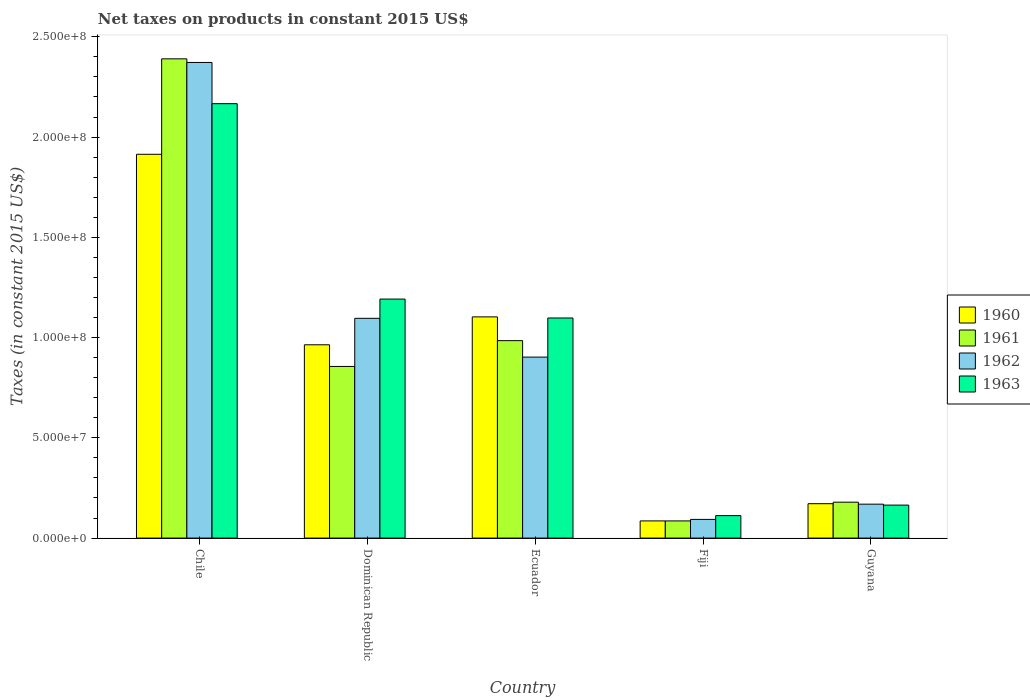How many different coloured bars are there?
Provide a succinct answer. 4. How many groups of bars are there?
Ensure brevity in your answer.  5. How many bars are there on the 5th tick from the right?
Offer a very short reply. 4. What is the label of the 5th group of bars from the left?
Offer a very short reply. Guyana. What is the net taxes on products in 1962 in Dominican Republic?
Keep it short and to the point. 1.10e+08. Across all countries, what is the maximum net taxes on products in 1963?
Make the answer very short. 2.17e+08. Across all countries, what is the minimum net taxes on products in 1963?
Give a very brief answer. 1.12e+07. In which country was the net taxes on products in 1962 minimum?
Keep it short and to the point. Fiji. What is the total net taxes on products in 1962 in the graph?
Your answer should be compact. 4.63e+08. What is the difference between the net taxes on products in 1961 in Chile and that in Ecuador?
Offer a terse response. 1.41e+08. What is the difference between the net taxes on products in 1963 in Dominican Republic and the net taxes on products in 1962 in Fiji?
Your response must be concise. 1.10e+08. What is the average net taxes on products in 1960 per country?
Your answer should be very brief. 8.48e+07. What is the difference between the net taxes on products of/in 1962 and net taxes on products of/in 1963 in Chile?
Provide a short and direct response. 2.06e+07. In how many countries, is the net taxes on products in 1961 greater than 230000000 US$?
Offer a very short reply. 1. What is the ratio of the net taxes on products in 1960 in Fiji to that in Guyana?
Offer a very short reply. 0.5. Is the net taxes on products in 1960 in Dominican Republic less than that in Fiji?
Offer a very short reply. No. What is the difference between the highest and the second highest net taxes on products in 1961?
Ensure brevity in your answer.  -1.29e+07. What is the difference between the highest and the lowest net taxes on products in 1962?
Your answer should be very brief. 2.28e+08. In how many countries, is the net taxes on products in 1960 greater than the average net taxes on products in 1960 taken over all countries?
Offer a very short reply. 3. Is the sum of the net taxes on products in 1961 in Chile and Dominican Republic greater than the maximum net taxes on products in 1962 across all countries?
Provide a short and direct response. Yes. Is it the case that in every country, the sum of the net taxes on products in 1962 and net taxes on products in 1960 is greater than the sum of net taxes on products in 1961 and net taxes on products in 1963?
Your answer should be compact. No. What does the 1st bar from the left in Ecuador represents?
Your answer should be compact. 1960. What does the 1st bar from the right in Dominican Republic represents?
Your answer should be compact. 1963. Is it the case that in every country, the sum of the net taxes on products in 1962 and net taxes on products in 1961 is greater than the net taxes on products in 1960?
Provide a succinct answer. Yes. Does the graph contain grids?
Give a very brief answer. No. Where does the legend appear in the graph?
Provide a short and direct response. Center right. How many legend labels are there?
Provide a short and direct response. 4. What is the title of the graph?
Make the answer very short. Net taxes on products in constant 2015 US$. Does "1969" appear as one of the legend labels in the graph?
Ensure brevity in your answer.  No. What is the label or title of the Y-axis?
Give a very brief answer. Taxes (in constant 2015 US$). What is the Taxes (in constant 2015 US$) of 1960 in Chile?
Give a very brief answer. 1.91e+08. What is the Taxes (in constant 2015 US$) of 1961 in Chile?
Ensure brevity in your answer.  2.39e+08. What is the Taxes (in constant 2015 US$) in 1962 in Chile?
Give a very brief answer. 2.37e+08. What is the Taxes (in constant 2015 US$) in 1963 in Chile?
Your answer should be compact. 2.17e+08. What is the Taxes (in constant 2015 US$) in 1960 in Dominican Republic?
Offer a very short reply. 9.64e+07. What is the Taxes (in constant 2015 US$) in 1961 in Dominican Republic?
Give a very brief answer. 8.56e+07. What is the Taxes (in constant 2015 US$) in 1962 in Dominican Republic?
Offer a terse response. 1.10e+08. What is the Taxes (in constant 2015 US$) of 1963 in Dominican Republic?
Your answer should be very brief. 1.19e+08. What is the Taxes (in constant 2015 US$) in 1960 in Ecuador?
Keep it short and to the point. 1.10e+08. What is the Taxes (in constant 2015 US$) in 1961 in Ecuador?
Ensure brevity in your answer.  9.85e+07. What is the Taxes (in constant 2015 US$) of 1962 in Ecuador?
Your response must be concise. 9.03e+07. What is the Taxes (in constant 2015 US$) of 1963 in Ecuador?
Make the answer very short. 1.10e+08. What is the Taxes (in constant 2015 US$) of 1960 in Fiji?
Make the answer very short. 8.56e+06. What is the Taxes (in constant 2015 US$) in 1961 in Fiji?
Offer a terse response. 8.56e+06. What is the Taxes (in constant 2015 US$) of 1962 in Fiji?
Provide a short and direct response. 9.32e+06. What is the Taxes (in constant 2015 US$) of 1963 in Fiji?
Your response must be concise. 1.12e+07. What is the Taxes (in constant 2015 US$) of 1960 in Guyana?
Offer a terse response. 1.71e+07. What is the Taxes (in constant 2015 US$) in 1961 in Guyana?
Keep it short and to the point. 1.79e+07. What is the Taxes (in constant 2015 US$) in 1962 in Guyana?
Offer a terse response. 1.69e+07. What is the Taxes (in constant 2015 US$) of 1963 in Guyana?
Your response must be concise. 1.64e+07. Across all countries, what is the maximum Taxes (in constant 2015 US$) in 1960?
Provide a succinct answer. 1.91e+08. Across all countries, what is the maximum Taxes (in constant 2015 US$) in 1961?
Give a very brief answer. 2.39e+08. Across all countries, what is the maximum Taxes (in constant 2015 US$) of 1962?
Make the answer very short. 2.37e+08. Across all countries, what is the maximum Taxes (in constant 2015 US$) in 1963?
Provide a succinct answer. 2.17e+08. Across all countries, what is the minimum Taxes (in constant 2015 US$) of 1960?
Your response must be concise. 8.56e+06. Across all countries, what is the minimum Taxes (in constant 2015 US$) of 1961?
Make the answer very short. 8.56e+06. Across all countries, what is the minimum Taxes (in constant 2015 US$) of 1962?
Offer a very short reply. 9.32e+06. Across all countries, what is the minimum Taxes (in constant 2015 US$) in 1963?
Provide a succinct answer. 1.12e+07. What is the total Taxes (in constant 2015 US$) of 1960 in the graph?
Ensure brevity in your answer.  4.24e+08. What is the total Taxes (in constant 2015 US$) in 1961 in the graph?
Your answer should be very brief. 4.50e+08. What is the total Taxes (in constant 2015 US$) in 1962 in the graph?
Your answer should be compact. 4.63e+08. What is the total Taxes (in constant 2015 US$) in 1963 in the graph?
Give a very brief answer. 4.73e+08. What is the difference between the Taxes (in constant 2015 US$) of 1960 in Chile and that in Dominican Republic?
Offer a terse response. 9.50e+07. What is the difference between the Taxes (in constant 2015 US$) of 1961 in Chile and that in Dominican Republic?
Your answer should be very brief. 1.53e+08. What is the difference between the Taxes (in constant 2015 US$) of 1962 in Chile and that in Dominican Republic?
Offer a very short reply. 1.28e+08. What is the difference between the Taxes (in constant 2015 US$) of 1963 in Chile and that in Dominican Republic?
Your answer should be very brief. 9.74e+07. What is the difference between the Taxes (in constant 2015 US$) in 1960 in Chile and that in Ecuador?
Offer a very short reply. 8.11e+07. What is the difference between the Taxes (in constant 2015 US$) of 1961 in Chile and that in Ecuador?
Ensure brevity in your answer.  1.41e+08. What is the difference between the Taxes (in constant 2015 US$) of 1962 in Chile and that in Ecuador?
Give a very brief answer. 1.47e+08. What is the difference between the Taxes (in constant 2015 US$) in 1963 in Chile and that in Ecuador?
Give a very brief answer. 1.07e+08. What is the difference between the Taxes (in constant 2015 US$) of 1960 in Chile and that in Fiji?
Provide a succinct answer. 1.83e+08. What is the difference between the Taxes (in constant 2015 US$) in 1961 in Chile and that in Fiji?
Your answer should be very brief. 2.30e+08. What is the difference between the Taxes (in constant 2015 US$) in 1962 in Chile and that in Fiji?
Offer a terse response. 2.28e+08. What is the difference between the Taxes (in constant 2015 US$) of 1963 in Chile and that in Fiji?
Keep it short and to the point. 2.05e+08. What is the difference between the Taxes (in constant 2015 US$) in 1960 in Chile and that in Guyana?
Offer a terse response. 1.74e+08. What is the difference between the Taxes (in constant 2015 US$) in 1961 in Chile and that in Guyana?
Ensure brevity in your answer.  2.21e+08. What is the difference between the Taxes (in constant 2015 US$) of 1962 in Chile and that in Guyana?
Your answer should be very brief. 2.20e+08. What is the difference between the Taxes (in constant 2015 US$) in 1963 in Chile and that in Guyana?
Your response must be concise. 2.00e+08. What is the difference between the Taxes (in constant 2015 US$) in 1960 in Dominican Republic and that in Ecuador?
Your answer should be compact. -1.39e+07. What is the difference between the Taxes (in constant 2015 US$) of 1961 in Dominican Republic and that in Ecuador?
Offer a very short reply. -1.29e+07. What is the difference between the Taxes (in constant 2015 US$) in 1962 in Dominican Republic and that in Ecuador?
Your answer should be very brief. 1.93e+07. What is the difference between the Taxes (in constant 2015 US$) in 1963 in Dominican Republic and that in Ecuador?
Offer a terse response. 9.44e+06. What is the difference between the Taxes (in constant 2015 US$) in 1960 in Dominican Republic and that in Fiji?
Offer a very short reply. 8.78e+07. What is the difference between the Taxes (in constant 2015 US$) of 1961 in Dominican Republic and that in Fiji?
Offer a very short reply. 7.70e+07. What is the difference between the Taxes (in constant 2015 US$) in 1962 in Dominican Republic and that in Fiji?
Keep it short and to the point. 1.00e+08. What is the difference between the Taxes (in constant 2015 US$) in 1963 in Dominican Republic and that in Fiji?
Keep it short and to the point. 1.08e+08. What is the difference between the Taxes (in constant 2015 US$) of 1960 in Dominican Republic and that in Guyana?
Give a very brief answer. 7.93e+07. What is the difference between the Taxes (in constant 2015 US$) of 1961 in Dominican Republic and that in Guyana?
Ensure brevity in your answer.  6.77e+07. What is the difference between the Taxes (in constant 2015 US$) of 1962 in Dominican Republic and that in Guyana?
Give a very brief answer. 9.27e+07. What is the difference between the Taxes (in constant 2015 US$) in 1963 in Dominican Republic and that in Guyana?
Your answer should be compact. 1.03e+08. What is the difference between the Taxes (in constant 2015 US$) of 1960 in Ecuador and that in Fiji?
Keep it short and to the point. 1.02e+08. What is the difference between the Taxes (in constant 2015 US$) in 1961 in Ecuador and that in Fiji?
Your answer should be very brief. 8.99e+07. What is the difference between the Taxes (in constant 2015 US$) in 1962 in Ecuador and that in Fiji?
Provide a succinct answer. 8.09e+07. What is the difference between the Taxes (in constant 2015 US$) in 1963 in Ecuador and that in Fiji?
Your response must be concise. 9.86e+07. What is the difference between the Taxes (in constant 2015 US$) of 1960 in Ecuador and that in Guyana?
Your answer should be very brief. 9.32e+07. What is the difference between the Taxes (in constant 2015 US$) in 1961 in Ecuador and that in Guyana?
Your answer should be very brief. 8.06e+07. What is the difference between the Taxes (in constant 2015 US$) in 1962 in Ecuador and that in Guyana?
Offer a terse response. 7.33e+07. What is the difference between the Taxes (in constant 2015 US$) of 1963 in Ecuador and that in Guyana?
Provide a succinct answer. 9.33e+07. What is the difference between the Taxes (in constant 2015 US$) in 1960 in Fiji and that in Guyana?
Ensure brevity in your answer.  -8.59e+06. What is the difference between the Taxes (in constant 2015 US$) of 1961 in Fiji and that in Guyana?
Your answer should be very brief. -9.34e+06. What is the difference between the Taxes (in constant 2015 US$) in 1962 in Fiji and that in Guyana?
Give a very brief answer. -7.60e+06. What is the difference between the Taxes (in constant 2015 US$) of 1963 in Fiji and that in Guyana?
Ensure brevity in your answer.  -5.24e+06. What is the difference between the Taxes (in constant 2015 US$) of 1960 in Chile and the Taxes (in constant 2015 US$) of 1961 in Dominican Republic?
Your answer should be compact. 1.06e+08. What is the difference between the Taxes (in constant 2015 US$) of 1960 in Chile and the Taxes (in constant 2015 US$) of 1962 in Dominican Republic?
Keep it short and to the point. 8.18e+07. What is the difference between the Taxes (in constant 2015 US$) of 1960 in Chile and the Taxes (in constant 2015 US$) of 1963 in Dominican Republic?
Provide a succinct answer. 7.22e+07. What is the difference between the Taxes (in constant 2015 US$) in 1961 in Chile and the Taxes (in constant 2015 US$) in 1962 in Dominican Republic?
Your response must be concise. 1.29e+08. What is the difference between the Taxes (in constant 2015 US$) of 1961 in Chile and the Taxes (in constant 2015 US$) of 1963 in Dominican Republic?
Offer a very short reply. 1.20e+08. What is the difference between the Taxes (in constant 2015 US$) of 1962 in Chile and the Taxes (in constant 2015 US$) of 1963 in Dominican Republic?
Give a very brief answer. 1.18e+08. What is the difference between the Taxes (in constant 2015 US$) in 1960 in Chile and the Taxes (in constant 2015 US$) in 1961 in Ecuador?
Your answer should be compact. 9.29e+07. What is the difference between the Taxes (in constant 2015 US$) in 1960 in Chile and the Taxes (in constant 2015 US$) in 1962 in Ecuador?
Offer a terse response. 1.01e+08. What is the difference between the Taxes (in constant 2015 US$) of 1960 in Chile and the Taxes (in constant 2015 US$) of 1963 in Ecuador?
Provide a short and direct response. 8.16e+07. What is the difference between the Taxes (in constant 2015 US$) of 1961 in Chile and the Taxes (in constant 2015 US$) of 1962 in Ecuador?
Offer a very short reply. 1.49e+08. What is the difference between the Taxes (in constant 2015 US$) of 1961 in Chile and the Taxes (in constant 2015 US$) of 1963 in Ecuador?
Make the answer very short. 1.29e+08. What is the difference between the Taxes (in constant 2015 US$) in 1962 in Chile and the Taxes (in constant 2015 US$) in 1963 in Ecuador?
Provide a short and direct response. 1.27e+08. What is the difference between the Taxes (in constant 2015 US$) of 1960 in Chile and the Taxes (in constant 2015 US$) of 1961 in Fiji?
Provide a succinct answer. 1.83e+08. What is the difference between the Taxes (in constant 2015 US$) of 1960 in Chile and the Taxes (in constant 2015 US$) of 1962 in Fiji?
Provide a succinct answer. 1.82e+08. What is the difference between the Taxes (in constant 2015 US$) in 1960 in Chile and the Taxes (in constant 2015 US$) in 1963 in Fiji?
Provide a short and direct response. 1.80e+08. What is the difference between the Taxes (in constant 2015 US$) of 1961 in Chile and the Taxes (in constant 2015 US$) of 1962 in Fiji?
Offer a very short reply. 2.30e+08. What is the difference between the Taxes (in constant 2015 US$) of 1961 in Chile and the Taxes (in constant 2015 US$) of 1963 in Fiji?
Give a very brief answer. 2.28e+08. What is the difference between the Taxes (in constant 2015 US$) in 1962 in Chile and the Taxes (in constant 2015 US$) in 1963 in Fiji?
Keep it short and to the point. 2.26e+08. What is the difference between the Taxes (in constant 2015 US$) of 1960 in Chile and the Taxes (in constant 2015 US$) of 1961 in Guyana?
Your answer should be very brief. 1.73e+08. What is the difference between the Taxes (in constant 2015 US$) in 1960 in Chile and the Taxes (in constant 2015 US$) in 1962 in Guyana?
Ensure brevity in your answer.  1.74e+08. What is the difference between the Taxes (in constant 2015 US$) in 1960 in Chile and the Taxes (in constant 2015 US$) in 1963 in Guyana?
Make the answer very short. 1.75e+08. What is the difference between the Taxes (in constant 2015 US$) in 1961 in Chile and the Taxes (in constant 2015 US$) in 1962 in Guyana?
Your answer should be compact. 2.22e+08. What is the difference between the Taxes (in constant 2015 US$) in 1961 in Chile and the Taxes (in constant 2015 US$) in 1963 in Guyana?
Keep it short and to the point. 2.23e+08. What is the difference between the Taxes (in constant 2015 US$) in 1962 in Chile and the Taxes (in constant 2015 US$) in 1963 in Guyana?
Keep it short and to the point. 2.21e+08. What is the difference between the Taxes (in constant 2015 US$) in 1960 in Dominican Republic and the Taxes (in constant 2015 US$) in 1961 in Ecuador?
Offer a very short reply. -2.07e+06. What is the difference between the Taxes (in constant 2015 US$) in 1960 in Dominican Republic and the Taxes (in constant 2015 US$) in 1962 in Ecuador?
Provide a succinct answer. 6.14e+06. What is the difference between the Taxes (in constant 2015 US$) of 1960 in Dominican Republic and the Taxes (in constant 2015 US$) of 1963 in Ecuador?
Give a very brief answer. -1.34e+07. What is the difference between the Taxes (in constant 2015 US$) of 1961 in Dominican Republic and the Taxes (in constant 2015 US$) of 1962 in Ecuador?
Provide a succinct answer. -4.66e+06. What is the difference between the Taxes (in constant 2015 US$) of 1961 in Dominican Republic and the Taxes (in constant 2015 US$) of 1963 in Ecuador?
Your response must be concise. -2.42e+07. What is the difference between the Taxes (in constant 2015 US$) of 1962 in Dominican Republic and the Taxes (in constant 2015 US$) of 1963 in Ecuador?
Provide a succinct answer. -1.64e+05. What is the difference between the Taxes (in constant 2015 US$) of 1960 in Dominican Republic and the Taxes (in constant 2015 US$) of 1961 in Fiji?
Offer a very short reply. 8.78e+07. What is the difference between the Taxes (in constant 2015 US$) of 1960 in Dominican Republic and the Taxes (in constant 2015 US$) of 1962 in Fiji?
Keep it short and to the point. 8.71e+07. What is the difference between the Taxes (in constant 2015 US$) of 1960 in Dominican Republic and the Taxes (in constant 2015 US$) of 1963 in Fiji?
Ensure brevity in your answer.  8.52e+07. What is the difference between the Taxes (in constant 2015 US$) of 1961 in Dominican Republic and the Taxes (in constant 2015 US$) of 1962 in Fiji?
Provide a short and direct response. 7.63e+07. What is the difference between the Taxes (in constant 2015 US$) of 1961 in Dominican Republic and the Taxes (in constant 2015 US$) of 1963 in Fiji?
Offer a very short reply. 7.44e+07. What is the difference between the Taxes (in constant 2015 US$) of 1962 in Dominican Republic and the Taxes (in constant 2015 US$) of 1963 in Fiji?
Keep it short and to the point. 9.84e+07. What is the difference between the Taxes (in constant 2015 US$) of 1960 in Dominican Republic and the Taxes (in constant 2015 US$) of 1961 in Guyana?
Your answer should be compact. 7.85e+07. What is the difference between the Taxes (in constant 2015 US$) in 1960 in Dominican Republic and the Taxes (in constant 2015 US$) in 1962 in Guyana?
Your answer should be compact. 7.95e+07. What is the difference between the Taxes (in constant 2015 US$) in 1960 in Dominican Republic and the Taxes (in constant 2015 US$) in 1963 in Guyana?
Provide a short and direct response. 8.00e+07. What is the difference between the Taxes (in constant 2015 US$) in 1961 in Dominican Republic and the Taxes (in constant 2015 US$) in 1962 in Guyana?
Offer a very short reply. 6.87e+07. What is the difference between the Taxes (in constant 2015 US$) in 1961 in Dominican Republic and the Taxes (in constant 2015 US$) in 1963 in Guyana?
Offer a terse response. 6.92e+07. What is the difference between the Taxes (in constant 2015 US$) of 1962 in Dominican Republic and the Taxes (in constant 2015 US$) of 1963 in Guyana?
Your response must be concise. 9.32e+07. What is the difference between the Taxes (in constant 2015 US$) of 1960 in Ecuador and the Taxes (in constant 2015 US$) of 1961 in Fiji?
Offer a terse response. 1.02e+08. What is the difference between the Taxes (in constant 2015 US$) in 1960 in Ecuador and the Taxes (in constant 2015 US$) in 1962 in Fiji?
Keep it short and to the point. 1.01e+08. What is the difference between the Taxes (in constant 2015 US$) in 1960 in Ecuador and the Taxes (in constant 2015 US$) in 1963 in Fiji?
Ensure brevity in your answer.  9.91e+07. What is the difference between the Taxes (in constant 2015 US$) in 1961 in Ecuador and the Taxes (in constant 2015 US$) in 1962 in Fiji?
Make the answer very short. 8.91e+07. What is the difference between the Taxes (in constant 2015 US$) of 1961 in Ecuador and the Taxes (in constant 2015 US$) of 1963 in Fiji?
Keep it short and to the point. 8.73e+07. What is the difference between the Taxes (in constant 2015 US$) in 1962 in Ecuador and the Taxes (in constant 2015 US$) in 1963 in Fiji?
Your answer should be compact. 7.91e+07. What is the difference between the Taxes (in constant 2015 US$) of 1960 in Ecuador and the Taxes (in constant 2015 US$) of 1961 in Guyana?
Keep it short and to the point. 9.24e+07. What is the difference between the Taxes (in constant 2015 US$) in 1960 in Ecuador and the Taxes (in constant 2015 US$) in 1962 in Guyana?
Offer a very short reply. 9.34e+07. What is the difference between the Taxes (in constant 2015 US$) in 1960 in Ecuador and the Taxes (in constant 2015 US$) in 1963 in Guyana?
Ensure brevity in your answer.  9.39e+07. What is the difference between the Taxes (in constant 2015 US$) in 1961 in Ecuador and the Taxes (in constant 2015 US$) in 1962 in Guyana?
Give a very brief answer. 8.16e+07. What is the difference between the Taxes (in constant 2015 US$) in 1961 in Ecuador and the Taxes (in constant 2015 US$) in 1963 in Guyana?
Your response must be concise. 8.20e+07. What is the difference between the Taxes (in constant 2015 US$) in 1962 in Ecuador and the Taxes (in constant 2015 US$) in 1963 in Guyana?
Your answer should be compact. 7.38e+07. What is the difference between the Taxes (in constant 2015 US$) in 1960 in Fiji and the Taxes (in constant 2015 US$) in 1961 in Guyana?
Your response must be concise. -9.34e+06. What is the difference between the Taxes (in constant 2015 US$) in 1960 in Fiji and the Taxes (in constant 2015 US$) in 1962 in Guyana?
Keep it short and to the point. -8.35e+06. What is the difference between the Taxes (in constant 2015 US$) in 1960 in Fiji and the Taxes (in constant 2015 US$) in 1963 in Guyana?
Your response must be concise. -7.89e+06. What is the difference between the Taxes (in constant 2015 US$) of 1961 in Fiji and the Taxes (in constant 2015 US$) of 1962 in Guyana?
Keep it short and to the point. -8.35e+06. What is the difference between the Taxes (in constant 2015 US$) of 1961 in Fiji and the Taxes (in constant 2015 US$) of 1963 in Guyana?
Give a very brief answer. -7.89e+06. What is the difference between the Taxes (in constant 2015 US$) of 1962 in Fiji and the Taxes (in constant 2015 US$) of 1963 in Guyana?
Keep it short and to the point. -7.13e+06. What is the average Taxes (in constant 2015 US$) in 1960 per country?
Offer a terse response. 8.48e+07. What is the average Taxes (in constant 2015 US$) in 1961 per country?
Your answer should be compact. 8.99e+07. What is the average Taxes (in constant 2015 US$) of 1962 per country?
Offer a terse response. 9.27e+07. What is the average Taxes (in constant 2015 US$) in 1963 per country?
Keep it short and to the point. 9.47e+07. What is the difference between the Taxes (in constant 2015 US$) of 1960 and Taxes (in constant 2015 US$) of 1961 in Chile?
Make the answer very short. -4.76e+07. What is the difference between the Taxes (in constant 2015 US$) in 1960 and Taxes (in constant 2015 US$) in 1962 in Chile?
Your answer should be very brief. -4.58e+07. What is the difference between the Taxes (in constant 2015 US$) in 1960 and Taxes (in constant 2015 US$) in 1963 in Chile?
Keep it short and to the point. -2.52e+07. What is the difference between the Taxes (in constant 2015 US$) of 1961 and Taxes (in constant 2015 US$) of 1962 in Chile?
Provide a succinct answer. 1.81e+06. What is the difference between the Taxes (in constant 2015 US$) in 1961 and Taxes (in constant 2015 US$) in 1963 in Chile?
Provide a succinct answer. 2.24e+07. What is the difference between the Taxes (in constant 2015 US$) of 1962 and Taxes (in constant 2015 US$) of 1963 in Chile?
Offer a terse response. 2.06e+07. What is the difference between the Taxes (in constant 2015 US$) in 1960 and Taxes (in constant 2015 US$) in 1961 in Dominican Republic?
Offer a terse response. 1.08e+07. What is the difference between the Taxes (in constant 2015 US$) in 1960 and Taxes (in constant 2015 US$) in 1962 in Dominican Republic?
Provide a short and direct response. -1.32e+07. What is the difference between the Taxes (in constant 2015 US$) of 1960 and Taxes (in constant 2015 US$) of 1963 in Dominican Republic?
Give a very brief answer. -2.28e+07. What is the difference between the Taxes (in constant 2015 US$) of 1961 and Taxes (in constant 2015 US$) of 1962 in Dominican Republic?
Provide a succinct answer. -2.40e+07. What is the difference between the Taxes (in constant 2015 US$) of 1961 and Taxes (in constant 2015 US$) of 1963 in Dominican Republic?
Make the answer very short. -3.36e+07. What is the difference between the Taxes (in constant 2015 US$) in 1962 and Taxes (in constant 2015 US$) in 1963 in Dominican Republic?
Provide a succinct answer. -9.60e+06. What is the difference between the Taxes (in constant 2015 US$) in 1960 and Taxes (in constant 2015 US$) in 1961 in Ecuador?
Give a very brief answer. 1.19e+07. What is the difference between the Taxes (in constant 2015 US$) in 1960 and Taxes (in constant 2015 US$) in 1962 in Ecuador?
Provide a succinct answer. 2.01e+07. What is the difference between the Taxes (in constant 2015 US$) in 1960 and Taxes (in constant 2015 US$) in 1963 in Ecuador?
Provide a succinct answer. 5.57e+05. What is the difference between the Taxes (in constant 2015 US$) of 1961 and Taxes (in constant 2015 US$) of 1962 in Ecuador?
Offer a very short reply. 8.21e+06. What is the difference between the Taxes (in constant 2015 US$) of 1961 and Taxes (in constant 2015 US$) of 1963 in Ecuador?
Provide a succinct answer. -1.13e+07. What is the difference between the Taxes (in constant 2015 US$) in 1962 and Taxes (in constant 2015 US$) in 1963 in Ecuador?
Ensure brevity in your answer.  -1.95e+07. What is the difference between the Taxes (in constant 2015 US$) in 1960 and Taxes (in constant 2015 US$) in 1962 in Fiji?
Offer a terse response. -7.56e+05. What is the difference between the Taxes (in constant 2015 US$) in 1960 and Taxes (in constant 2015 US$) in 1963 in Fiji?
Provide a short and direct response. -2.64e+06. What is the difference between the Taxes (in constant 2015 US$) of 1961 and Taxes (in constant 2015 US$) of 1962 in Fiji?
Provide a succinct answer. -7.56e+05. What is the difference between the Taxes (in constant 2015 US$) in 1961 and Taxes (in constant 2015 US$) in 1963 in Fiji?
Your response must be concise. -2.64e+06. What is the difference between the Taxes (in constant 2015 US$) in 1962 and Taxes (in constant 2015 US$) in 1963 in Fiji?
Keep it short and to the point. -1.89e+06. What is the difference between the Taxes (in constant 2015 US$) of 1960 and Taxes (in constant 2015 US$) of 1961 in Guyana?
Ensure brevity in your answer.  -7.58e+05. What is the difference between the Taxes (in constant 2015 US$) in 1960 and Taxes (in constant 2015 US$) in 1962 in Guyana?
Keep it short and to the point. 2.33e+05. What is the difference between the Taxes (in constant 2015 US$) in 1960 and Taxes (in constant 2015 US$) in 1963 in Guyana?
Provide a short and direct response. 7.00e+05. What is the difference between the Taxes (in constant 2015 US$) of 1961 and Taxes (in constant 2015 US$) of 1962 in Guyana?
Make the answer very short. 9.92e+05. What is the difference between the Taxes (in constant 2015 US$) of 1961 and Taxes (in constant 2015 US$) of 1963 in Guyana?
Ensure brevity in your answer.  1.46e+06. What is the difference between the Taxes (in constant 2015 US$) of 1962 and Taxes (in constant 2015 US$) of 1963 in Guyana?
Give a very brief answer. 4.67e+05. What is the ratio of the Taxes (in constant 2015 US$) in 1960 in Chile to that in Dominican Republic?
Ensure brevity in your answer.  1.99. What is the ratio of the Taxes (in constant 2015 US$) in 1961 in Chile to that in Dominican Republic?
Give a very brief answer. 2.79. What is the ratio of the Taxes (in constant 2015 US$) in 1962 in Chile to that in Dominican Republic?
Your response must be concise. 2.16. What is the ratio of the Taxes (in constant 2015 US$) in 1963 in Chile to that in Dominican Republic?
Your response must be concise. 1.82. What is the ratio of the Taxes (in constant 2015 US$) in 1960 in Chile to that in Ecuador?
Offer a very short reply. 1.74. What is the ratio of the Taxes (in constant 2015 US$) in 1961 in Chile to that in Ecuador?
Your response must be concise. 2.43. What is the ratio of the Taxes (in constant 2015 US$) of 1962 in Chile to that in Ecuador?
Offer a very short reply. 2.63. What is the ratio of the Taxes (in constant 2015 US$) in 1963 in Chile to that in Ecuador?
Your answer should be compact. 1.97. What is the ratio of the Taxes (in constant 2015 US$) in 1960 in Chile to that in Fiji?
Offer a very short reply. 22.35. What is the ratio of the Taxes (in constant 2015 US$) of 1961 in Chile to that in Fiji?
Make the answer very short. 27.91. What is the ratio of the Taxes (in constant 2015 US$) of 1962 in Chile to that in Fiji?
Provide a succinct answer. 25.45. What is the ratio of the Taxes (in constant 2015 US$) in 1963 in Chile to that in Fiji?
Keep it short and to the point. 19.33. What is the ratio of the Taxes (in constant 2015 US$) in 1960 in Chile to that in Guyana?
Offer a terse response. 11.16. What is the ratio of the Taxes (in constant 2015 US$) of 1961 in Chile to that in Guyana?
Offer a very short reply. 13.35. What is the ratio of the Taxes (in constant 2015 US$) of 1962 in Chile to that in Guyana?
Your answer should be very brief. 14.02. What is the ratio of the Taxes (in constant 2015 US$) of 1963 in Chile to that in Guyana?
Your answer should be very brief. 13.17. What is the ratio of the Taxes (in constant 2015 US$) in 1960 in Dominican Republic to that in Ecuador?
Give a very brief answer. 0.87. What is the ratio of the Taxes (in constant 2015 US$) in 1961 in Dominican Republic to that in Ecuador?
Provide a short and direct response. 0.87. What is the ratio of the Taxes (in constant 2015 US$) of 1962 in Dominican Republic to that in Ecuador?
Provide a short and direct response. 1.21. What is the ratio of the Taxes (in constant 2015 US$) in 1963 in Dominican Republic to that in Ecuador?
Your answer should be compact. 1.09. What is the ratio of the Taxes (in constant 2015 US$) in 1960 in Dominican Republic to that in Fiji?
Your answer should be compact. 11.26. What is the ratio of the Taxes (in constant 2015 US$) of 1961 in Dominican Republic to that in Fiji?
Your answer should be very brief. 10. What is the ratio of the Taxes (in constant 2015 US$) in 1962 in Dominican Republic to that in Fiji?
Provide a short and direct response. 11.76. What is the ratio of the Taxes (in constant 2015 US$) of 1963 in Dominican Republic to that in Fiji?
Your answer should be compact. 10.63. What is the ratio of the Taxes (in constant 2015 US$) of 1960 in Dominican Republic to that in Guyana?
Keep it short and to the point. 5.62. What is the ratio of the Taxes (in constant 2015 US$) in 1961 in Dominican Republic to that in Guyana?
Keep it short and to the point. 4.78. What is the ratio of the Taxes (in constant 2015 US$) of 1962 in Dominican Republic to that in Guyana?
Your answer should be very brief. 6.48. What is the ratio of the Taxes (in constant 2015 US$) in 1963 in Dominican Republic to that in Guyana?
Offer a terse response. 7.25. What is the ratio of the Taxes (in constant 2015 US$) in 1960 in Ecuador to that in Fiji?
Ensure brevity in your answer.  12.88. What is the ratio of the Taxes (in constant 2015 US$) in 1961 in Ecuador to that in Fiji?
Your response must be concise. 11.5. What is the ratio of the Taxes (in constant 2015 US$) in 1962 in Ecuador to that in Fiji?
Your answer should be very brief. 9.69. What is the ratio of the Taxes (in constant 2015 US$) of 1963 in Ecuador to that in Fiji?
Give a very brief answer. 9.79. What is the ratio of the Taxes (in constant 2015 US$) of 1960 in Ecuador to that in Guyana?
Provide a short and direct response. 6.43. What is the ratio of the Taxes (in constant 2015 US$) of 1961 in Ecuador to that in Guyana?
Your answer should be compact. 5.5. What is the ratio of the Taxes (in constant 2015 US$) in 1962 in Ecuador to that in Guyana?
Make the answer very short. 5.34. What is the ratio of the Taxes (in constant 2015 US$) of 1963 in Ecuador to that in Guyana?
Provide a short and direct response. 6.67. What is the ratio of the Taxes (in constant 2015 US$) of 1960 in Fiji to that in Guyana?
Provide a short and direct response. 0.5. What is the ratio of the Taxes (in constant 2015 US$) of 1961 in Fiji to that in Guyana?
Provide a short and direct response. 0.48. What is the ratio of the Taxes (in constant 2015 US$) of 1962 in Fiji to that in Guyana?
Your answer should be compact. 0.55. What is the ratio of the Taxes (in constant 2015 US$) in 1963 in Fiji to that in Guyana?
Ensure brevity in your answer.  0.68. What is the difference between the highest and the second highest Taxes (in constant 2015 US$) of 1960?
Offer a very short reply. 8.11e+07. What is the difference between the highest and the second highest Taxes (in constant 2015 US$) in 1961?
Provide a short and direct response. 1.41e+08. What is the difference between the highest and the second highest Taxes (in constant 2015 US$) of 1962?
Give a very brief answer. 1.28e+08. What is the difference between the highest and the second highest Taxes (in constant 2015 US$) of 1963?
Your answer should be very brief. 9.74e+07. What is the difference between the highest and the lowest Taxes (in constant 2015 US$) in 1960?
Your answer should be very brief. 1.83e+08. What is the difference between the highest and the lowest Taxes (in constant 2015 US$) in 1961?
Ensure brevity in your answer.  2.30e+08. What is the difference between the highest and the lowest Taxes (in constant 2015 US$) in 1962?
Offer a very short reply. 2.28e+08. What is the difference between the highest and the lowest Taxes (in constant 2015 US$) of 1963?
Keep it short and to the point. 2.05e+08. 